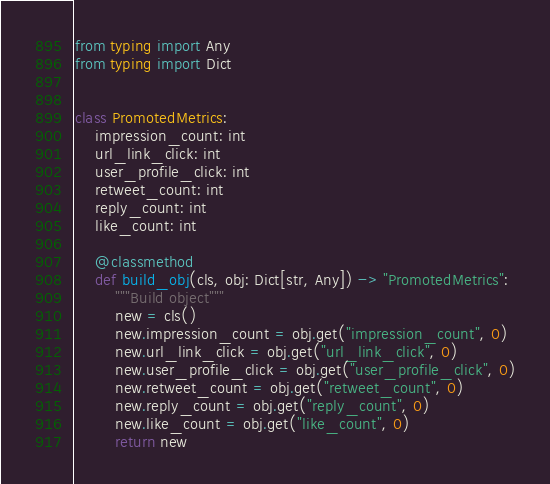<code> <loc_0><loc_0><loc_500><loc_500><_Python_>from typing import Any
from typing import Dict


class PromotedMetrics:
    impression_count: int
    url_link_click: int
    user_profile_click: int
    retweet_count: int
    reply_count: int
    like_count: int

    @classmethod
    def build_obj(cls, obj: Dict[str, Any]) -> "PromotedMetrics":
        """Build object"""
        new = cls()
        new.impression_count = obj.get("impression_count", 0)
        new.url_link_click = obj.get("url_link_click", 0)
        new.user_profile_click = obj.get("user_profile_click", 0)
        new.retweet_count = obj.get("retweet_count", 0)
        new.reply_count = obj.get("reply_count", 0)
        new.like_count = obj.get("like_count", 0)
        return new
</code> 